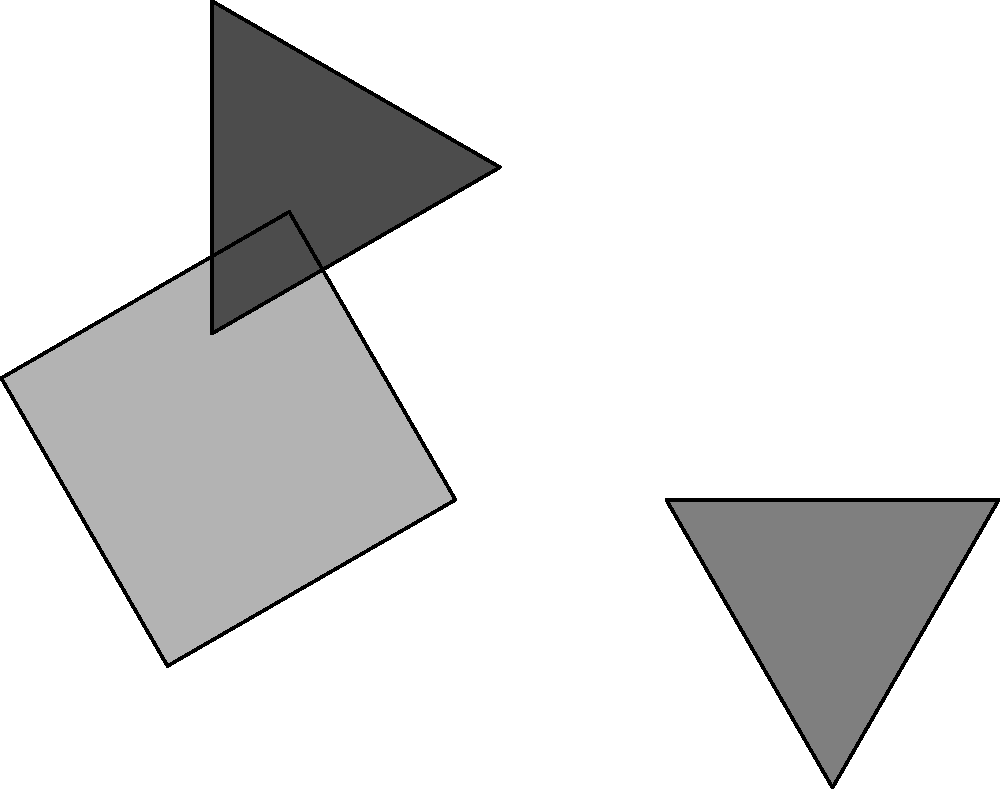A broken clay artifact has been discovered in the jungle. Three pieces of the artifact are shown above, each rotated and separated. Which of the following sequences of rotations will correctly assemble the artifact: 
A) Rotate piece 1 by -30°, piece 2 by 60°, and piece 3 by -120°
B) Rotate piece 1 by 30°, piece 2 by 60°, and piece 3 by 120°
C) Rotate piece 1 by -30°, piece 2 by -60°, and piece 3 by -120°
D) Rotate piece 1 by 30°, piece 2 by -60°, and piece 3 by 120° To solve this problem, we need to mentally rotate each piece to its correct position:

1. Piece 1 (lightest gray square):
   - It's currently rotated 30° clockwise
   - To return it to its original position, we need to rotate it 30° counterclockwise (-30°)

2. Piece 2 (medium gray triangle):
   - It's currently rotated 60° clockwise
   - To return it to its original position, we need to rotate it 60° counterclockwise (-60°)

3. Piece 3 (darkest gray triangle):
   - It's currently rotated 120° clockwise
   - To return it to its original position, we need to rotate it 120° counterclockwise (-120°)

Looking at the given options, we can see that option C matches these rotations exactly:
Rotate piece 1 by -30°, piece 2 by -60°, and piece 3 by -120°

This sequence of rotations will correctly assemble the artifact by returning each piece to its original position.
Answer: C 